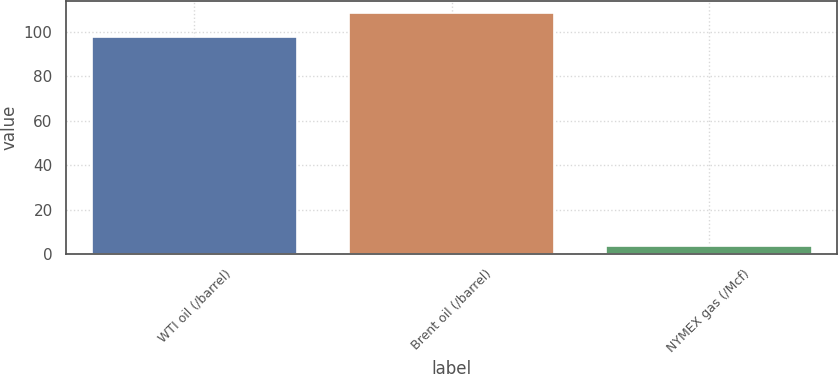<chart> <loc_0><loc_0><loc_500><loc_500><bar_chart><fcel>WTI oil (/barrel)<fcel>Brent oil (/barrel)<fcel>NYMEX gas (/Mcf)<nl><fcel>97.97<fcel>108.76<fcel>3.66<nl></chart> 